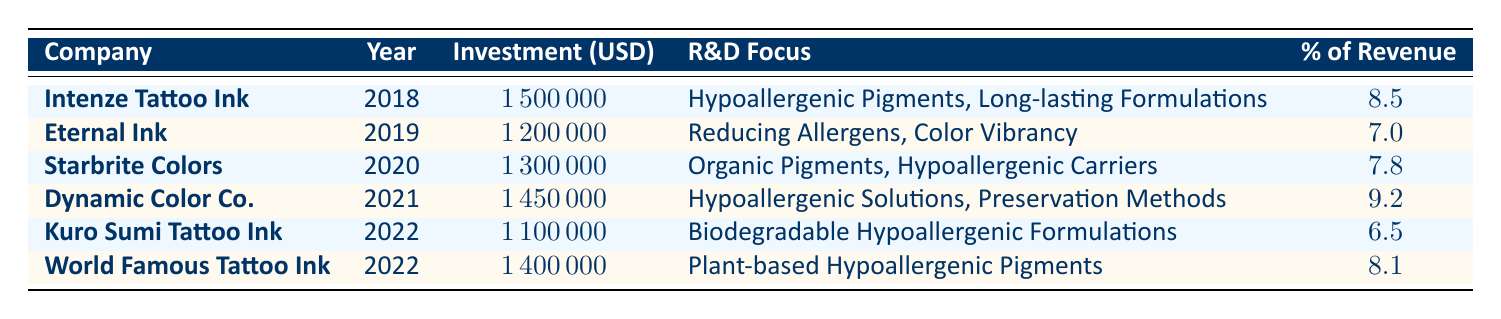What is the highest R&D investment made by a single company? By examining the 'Investment (USD)' column, the maximum value of 1,500,000 corresponds to Intenze Tattoo Ink in the year 2018. Therefore, the highest investment made by a single company is 1,500,000.
Answer: 1,500,000 Which company focused on biodegradable hypoallergenic formulations? Looking at the 'R&D Focus' column, Kuro Sumi Tattoo Ink in 2022 specifically mentions "Biodegradable Hypoallergenic Formulations". Thus, Kuro Sumi Tattoo Ink is the company with this focus.
Answer: Kuro Sumi Tattoo Ink What is the total investment in R&D for hypoallergenic inks from 2018 to 2022? To find the total investment, we add all the investments: 1,500,000 (2018) + 1,200,000 (2019) + 1,300,000 (2020) + 1,450,000 (2021) + 1,100,000 (2022, Kuro Sumi) + 1,400,000 (2022, World Famous) = 7,950,000.
Answer: 7,950,000 Did any company exceed 10% of revenue in their R&D investment in hypoallergenic inks? Evaluating the '% of Revenue' column, the maximum percentage is 9.2 for Dynamic Color Co. in 2021, which does not exceed 10%. So, no company exceeded 10% of revenue in their investment.
Answer: No What is the average percentage of total revenue invested in R&D for the listed companies? To calculate the average, we sum up all percentages: 8.5 + 7.0 + 7.8 + 9.2 + 6.5 + 8.1 = 47.1. Then we divide by the number of companies, which is 6. So, the average percentage is 47.1 / 6 = 7.85.
Answer: 7.85 